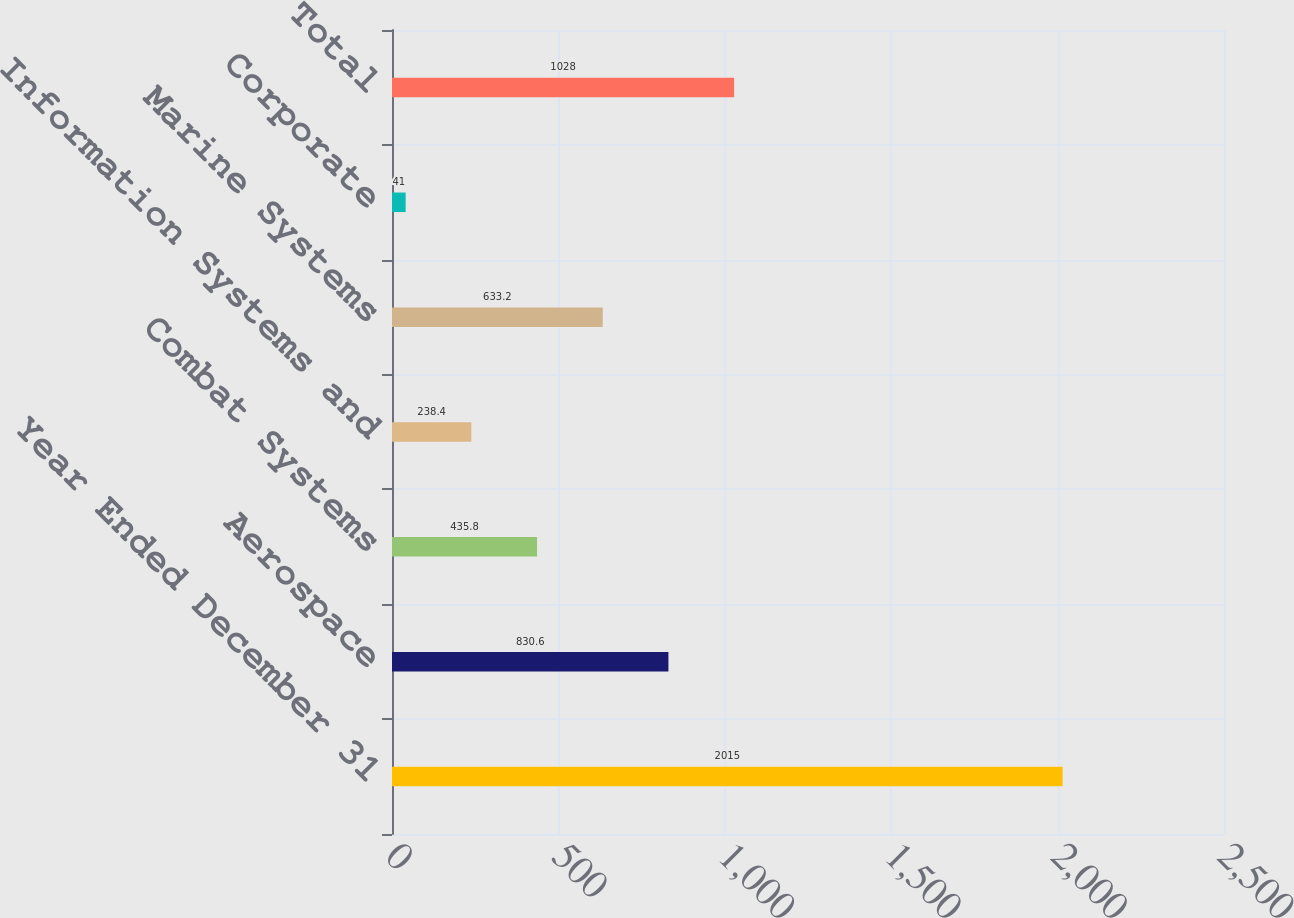Convert chart to OTSL. <chart><loc_0><loc_0><loc_500><loc_500><bar_chart><fcel>Year Ended December 31<fcel>Aerospace<fcel>Combat Systems<fcel>Information Systems and<fcel>Marine Systems<fcel>Corporate<fcel>Total<nl><fcel>2015<fcel>830.6<fcel>435.8<fcel>238.4<fcel>633.2<fcel>41<fcel>1028<nl></chart> 